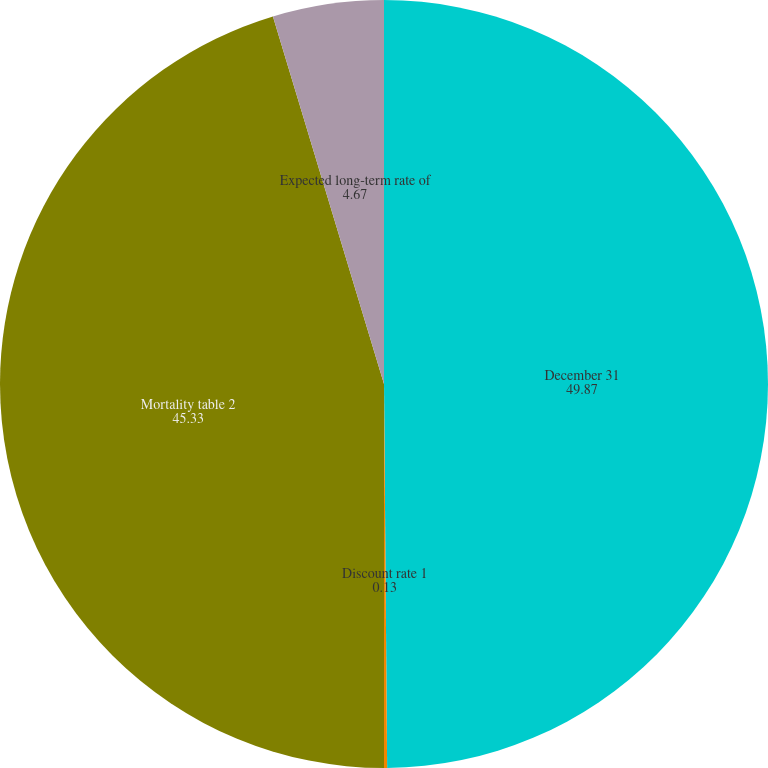<chart> <loc_0><loc_0><loc_500><loc_500><pie_chart><fcel>December 31<fcel>Discount rate 1<fcel>Mortality table 2<fcel>Expected long-term rate of<nl><fcel>49.87%<fcel>0.13%<fcel>45.33%<fcel>4.67%<nl></chart> 